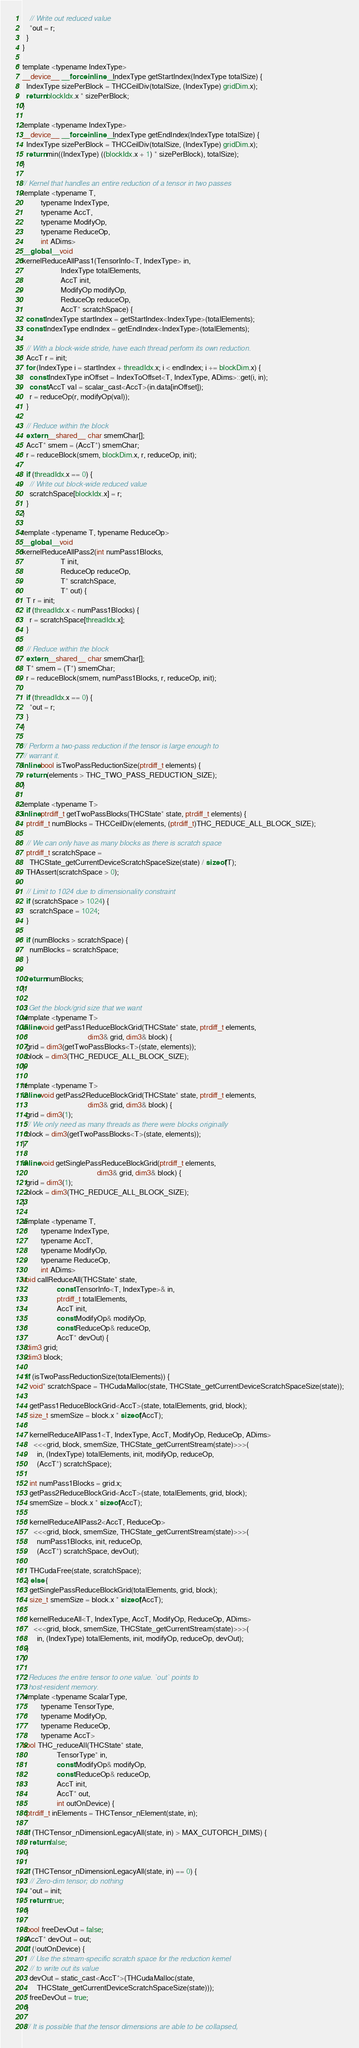<code> <loc_0><loc_0><loc_500><loc_500><_Cuda_>    // Write out reduced value
    *out = r;
  }
}

template <typename IndexType>
__device__ __forceinline__ IndexType getStartIndex(IndexType totalSize) {
  IndexType sizePerBlock = THCCeilDiv(totalSize, (IndexType) gridDim.x);
  return blockIdx.x * sizePerBlock;
}

template <typename IndexType>
__device__ __forceinline__ IndexType getEndIndex(IndexType totalSize) {
  IndexType sizePerBlock = THCCeilDiv(totalSize, (IndexType) gridDim.x);
  return min((IndexType) ((blockIdx.x + 1) * sizePerBlock), totalSize);
}

// Kernel that handles an entire reduction of a tensor in two passes
template <typename T,
          typename IndexType,
          typename AccT,
          typename ModifyOp,
          typename ReduceOp,
          int ADims>
__global__ void
kernelReduceAllPass1(TensorInfo<T, IndexType> in,
                     IndexType totalElements,
                     AccT init,
                     ModifyOp modifyOp,
                     ReduceOp reduceOp,
                     AccT* scratchSpace) {
  const IndexType startIndex = getStartIndex<IndexType>(totalElements);
  const IndexType endIndex = getEndIndex<IndexType>(totalElements);

  // With a block-wide stride, have each thread perform its own reduction.
  AccT r = init;
  for (IndexType i = startIndex + threadIdx.x; i < endIndex; i += blockDim.x) {
    const IndexType inOffset = IndexToOffset<T, IndexType, ADims>::get(i, in);
    const AccT val = scalar_cast<AccT>(in.data[inOffset]);
    r = reduceOp(r, modifyOp(val));
  }

  // Reduce within the block
  extern __shared__ char smemChar[];
  AccT* smem = (AccT*) smemChar;
  r = reduceBlock(smem, blockDim.x, r, reduceOp, init);

  if (threadIdx.x == 0) {
    // Write out block-wide reduced value
    scratchSpace[blockIdx.x] = r;
  }
}

template <typename T, typename ReduceOp>
__global__ void
kernelReduceAllPass2(int numPass1Blocks,
                     T init,
                     ReduceOp reduceOp,
                     T* scratchSpace,
                     T* out) {
  T r = init;
  if (threadIdx.x < numPass1Blocks) {
    r = scratchSpace[threadIdx.x];
  }

  // Reduce within the block
  extern __shared__ char smemChar[];
  T* smem = (T*) smemChar;
  r = reduceBlock(smem, numPass1Blocks, r, reduceOp, init);

  if (threadIdx.x == 0) {
    *out = r;
  }
}

// Perform a two-pass reduction if the tensor is large enough to
// warrant it.
inline bool isTwoPassReductionSize(ptrdiff_t elements) {
  return (elements > THC_TWO_PASS_REDUCTION_SIZE);
}

template <typename T>
inline ptrdiff_t getTwoPassBlocks(THCState* state, ptrdiff_t elements) {
  ptrdiff_t numBlocks = THCCeilDiv(elements, (ptrdiff_t)THC_REDUCE_ALL_BLOCK_SIZE);

  // We can only have as many blocks as there is scratch space
  ptrdiff_t scratchSpace =
    THCState_getCurrentDeviceScratchSpaceSize(state) / sizeof(T);
  THAssert(scratchSpace > 0);

  // Limit to 1024 due to dimensionality constraint
  if (scratchSpace > 1024) {
    scratchSpace = 1024;
  }

  if (numBlocks > scratchSpace) {
    numBlocks = scratchSpace;
  }

  return numBlocks;
}

// Get the block/grid size that we want
template <typename T>
inline void getPass1ReduceBlockGrid(THCState* state, ptrdiff_t elements,
                                    dim3& grid, dim3& block) {
  grid = dim3(getTwoPassBlocks<T>(state, elements));
  block = dim3(THC_REDUCE_ALL_BLOCK_SIZE);
}

template <typename T>
inline void getPass2ReduceBlockGrid(THCState* state, ptrdiff_t elements,
                                    dim3& grid, dim3& block) {
  grid = dim3(1);
  // We only need as many threads as there were blocks originally
  block = dim3(getTwoPassBlocks<T>(state, elements));
}

inline void getSinglePassReduceBlockGrid(ptrdiff_t elements,
                                         dim3& grid, dim3& block) {
  grid = dim3(1);
  block = dim3(THC_REDUCE_ALL_BLOCK_SIZE);
}

template <typename T,
          typename IndexType,
          typename AccT,
          typename ModifyOp,
          typename ReduceOp,
          int ADims>
void callReduceAll(THCState* state,
                   const TensorInfo<T, IndexType>& in,
                   ptrdiff_t totalElements,
                   AccT init,
                   const ModifyOp& modifyOp,
                   const ReduceOp& reduceOp,
                   AccT* devOut) {
  dim3 grid;
  dim3 block;

  if (isTwoPassReductionSize(totalElements)) {
    void* scratchSpace = THCudaMalloc(state, THCState_getCurrentDeviceScratchSpaceSize(state));

    getPass1ReduceBlockGrid<AccT>(state, totalElements, grid, block);
    size_t smemSize = block.x * sizeof(AccT);

    kernelReduceAllPass1<T, IndexType, AccT, ModifyOp, ReduceOp, ADims>
      <<<grid, block, smemSize, THCState_getCurrentStream(state)>>>(
        in, (IndexType) totalElements, init, modifyOp, reduceOp,
        (AccT*) scratchSpace);

    int numPass1Blocks = grid.x;
    getPass2ReduceBlockGrid<AccT>(state, totalElements, grid, block);
    smemSize = block.x * sizeof(AccT);

    kernelReduceAllPass2<AccT, ReduceOp>
      <<<grid, block, smemSize, THCState_getCurrentStream(state)>>>(
        numPass1Blocks, init, reduceOp,
        (AccT*) scratchSpace, devOut);

    THCudaFree(state, scratchSpace);
  } else {
    getSinglePassReduceBlockGrid(totalElements, grid, block);
    size_t smemSize = block.x * sizeof(AccT);

    kernelReduceAll<T, IndexType, AccT, ModifyOp, ReduceOp, ADims>
      <<<grid, block, smemSize, THCState_getCurrentStream(state)>>>(
        in, (IndexType) totalElements, init, modifyOp, reduceOp, devOut);
  }
}

// Reduces the entire tensor to one value. `out` points to
// host-resident memory.
template <typename ScalarType,
          typename TensorType,
          typename ModifyOp,
          typename ReduceOp,
          typename AccT>
bool THC_reduceAll(THCState* state,
                   TensorType* in,
                   const ModifyOp& modifyOp,
                   const ReduceOp& reduceOp,
                   AccT init,
                   AccT* out,
                   int outOnDevice) {
  ptrdiff_t inElements = THCTensor_nElement(state, in);

  if (THCTensor_nDimensionLegacyAll(state, in) > MAX_CUTORCH_DIMS) {
    return false;
  }

  if (THCTensor_nDimensionLegacyAll(state, in) == 0) {
    // Zero-dim tensor; do nothing
    *out = init;
    return true;
  }

  bool freeDevOut = false;
  AccT* devOut = out;
  if (!outOnDevice) {
    // Use the stream-specific scratch space for the reduction kernel
    // to write out its value
    devOut = static_cast<AccT*>(THCudaMalloc(state,
        THCState_getCurrentDeviceScratchSpaceSize(state)));
    freeDevOut = true;
  }

  // It is possible that the tensor dimensions are able to be collapsed,</code> 